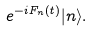<formula> <loc_0><loc_0><loc_500><loc_500>e ^ { - i F _ { n } ( t ) } | n \rangle .</formula> 